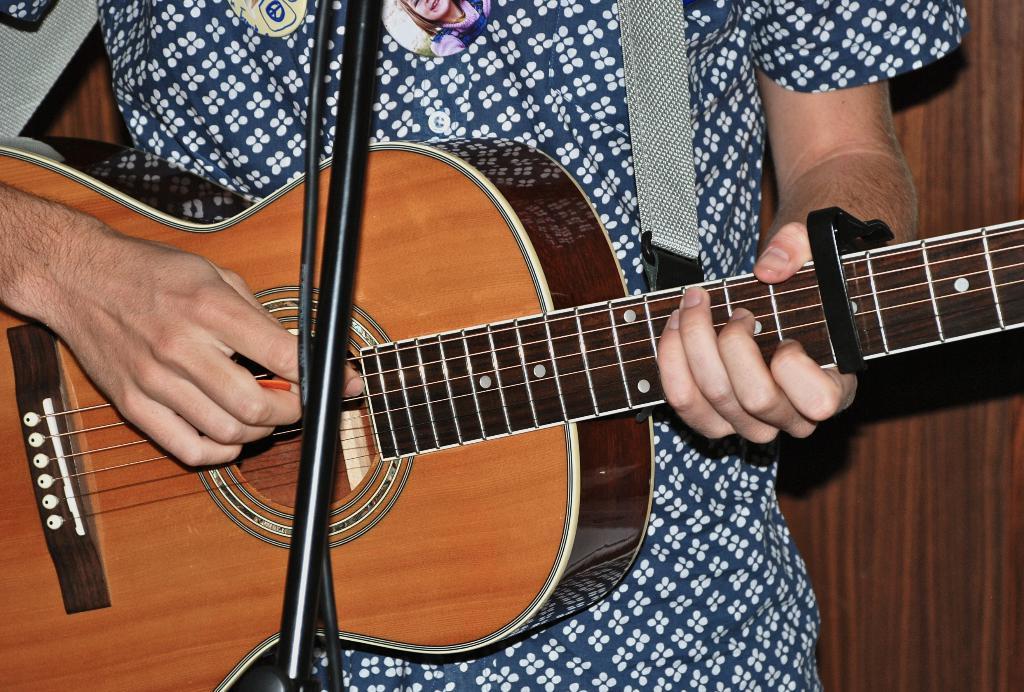Could you give a brief overview of what you see in this image? In the image there is a man playing a guitar. 